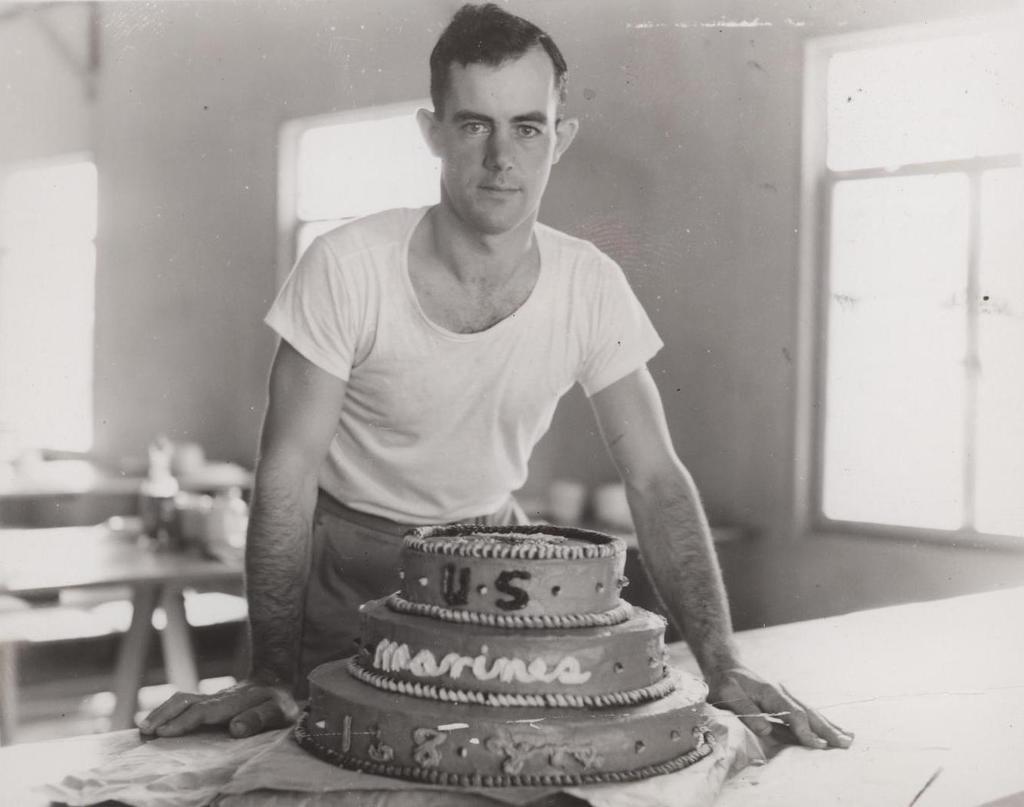How would you summarize this image in a sentence or two? There is a man standing in front of a cake which was placed on the table. In the background, there are some tables, windows and a wall here. 